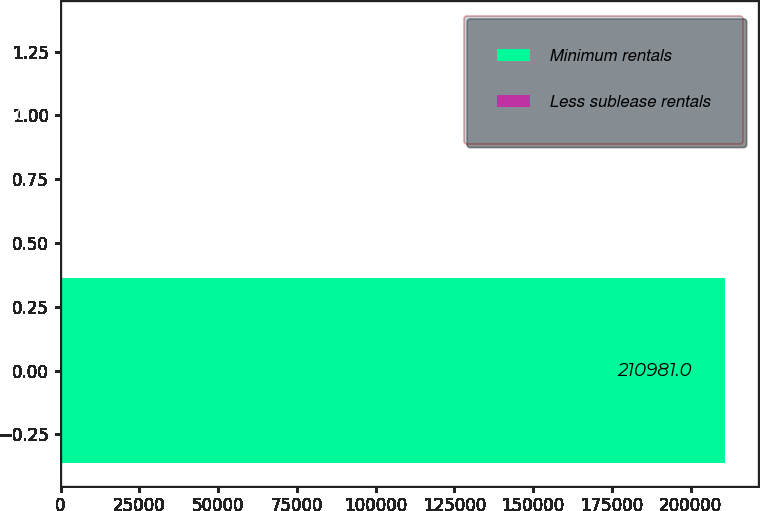Convert chart to OTSL. <chart><loc_0><loc_0><loc_500><loc_500><bar_chart><fcel>Minimum rentals<fcel>Less sublease rentals<nl><fcel>210981<fcel>218<nl></chart> 